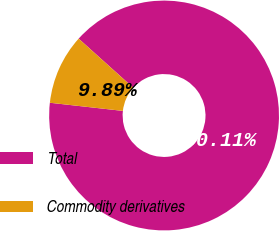Convert chart to OTSL. <chart><loc_0><loc_0><loc_500><loc_500><pie_chart><fcel>Total<fcel>Commodity derivatives<nl><fcel>90.11%<fcel>9.89%<nl></chart> 